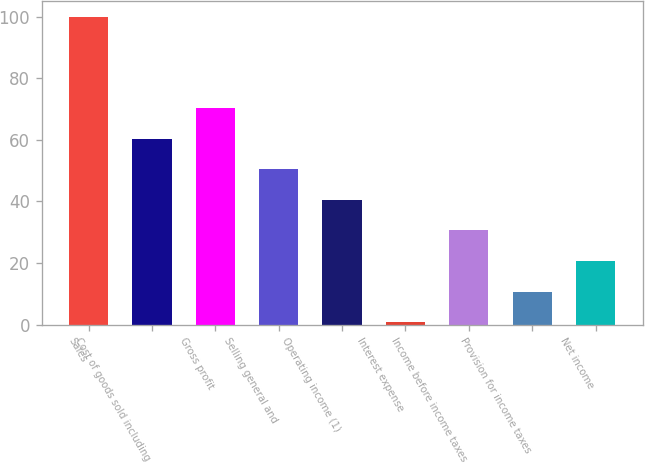Convert chart. <chart><loc_0><loc_0><loc_500><loc_500><bar_chart><fcel>Sales<fcel>Cost of goods sold including<fcel>Gross profit<fcel>Selling general and<fcel>Operating income (1)<fcel>Interest expense<fcel>Income before income taxes<fcel>Provision for income taxes<fcel>Net income<nl><fcel>100<fcel>60.32<fcel>70.24<fcel>50.4<fcel>40.48<fcel>0.8<fcel>30.56<fcel>10.72<fcel>20.64<nl></chart> 